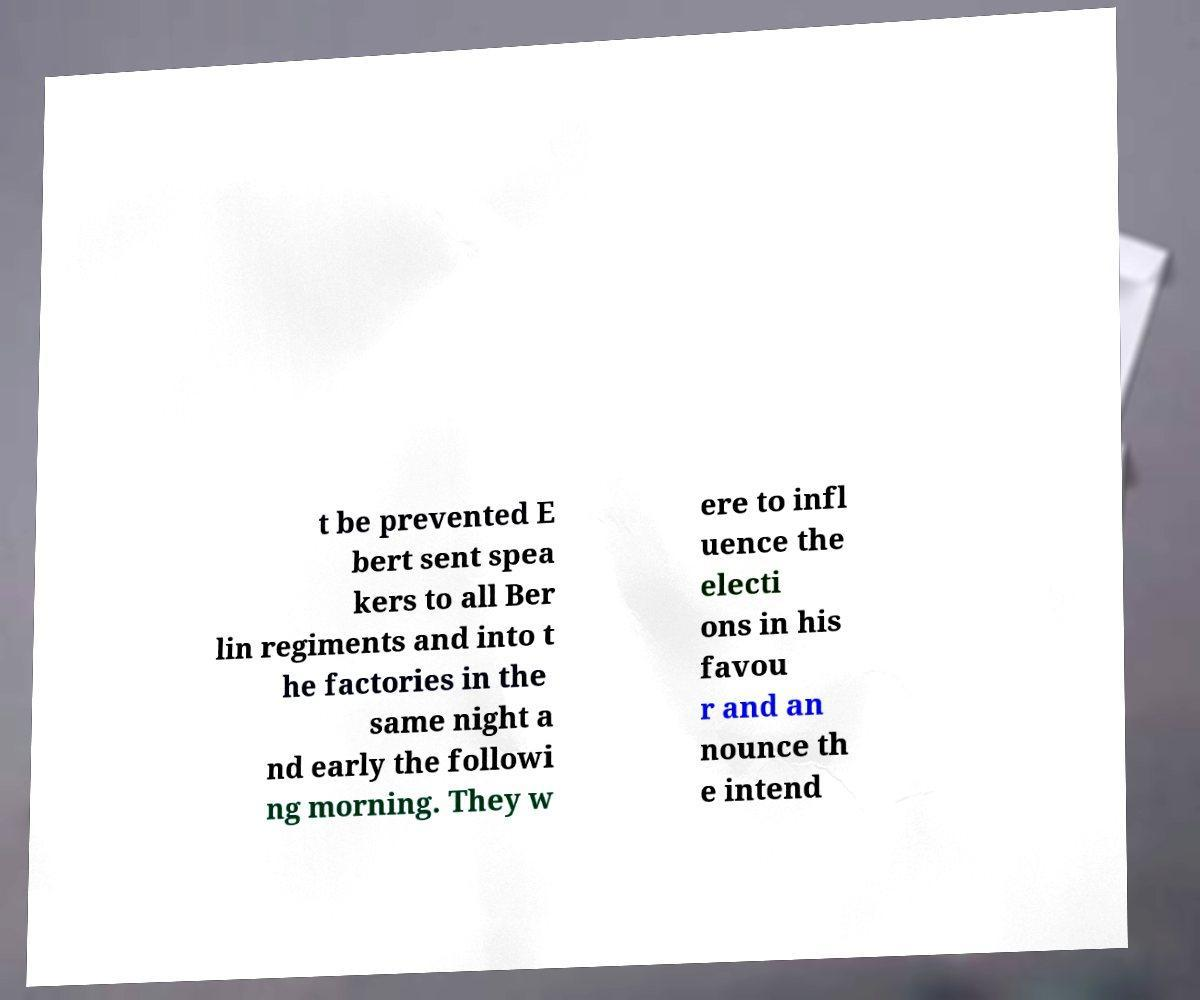For documentation purposes, I need the text within this image transcribed. Could you provide that? t be prevented E bert sent spea kers to all Ber lin regiments and into t he factories in the same night a nd early the followi ng morning. They w ere to infl uence the electi ons in his favou r and an nounce th e intend 